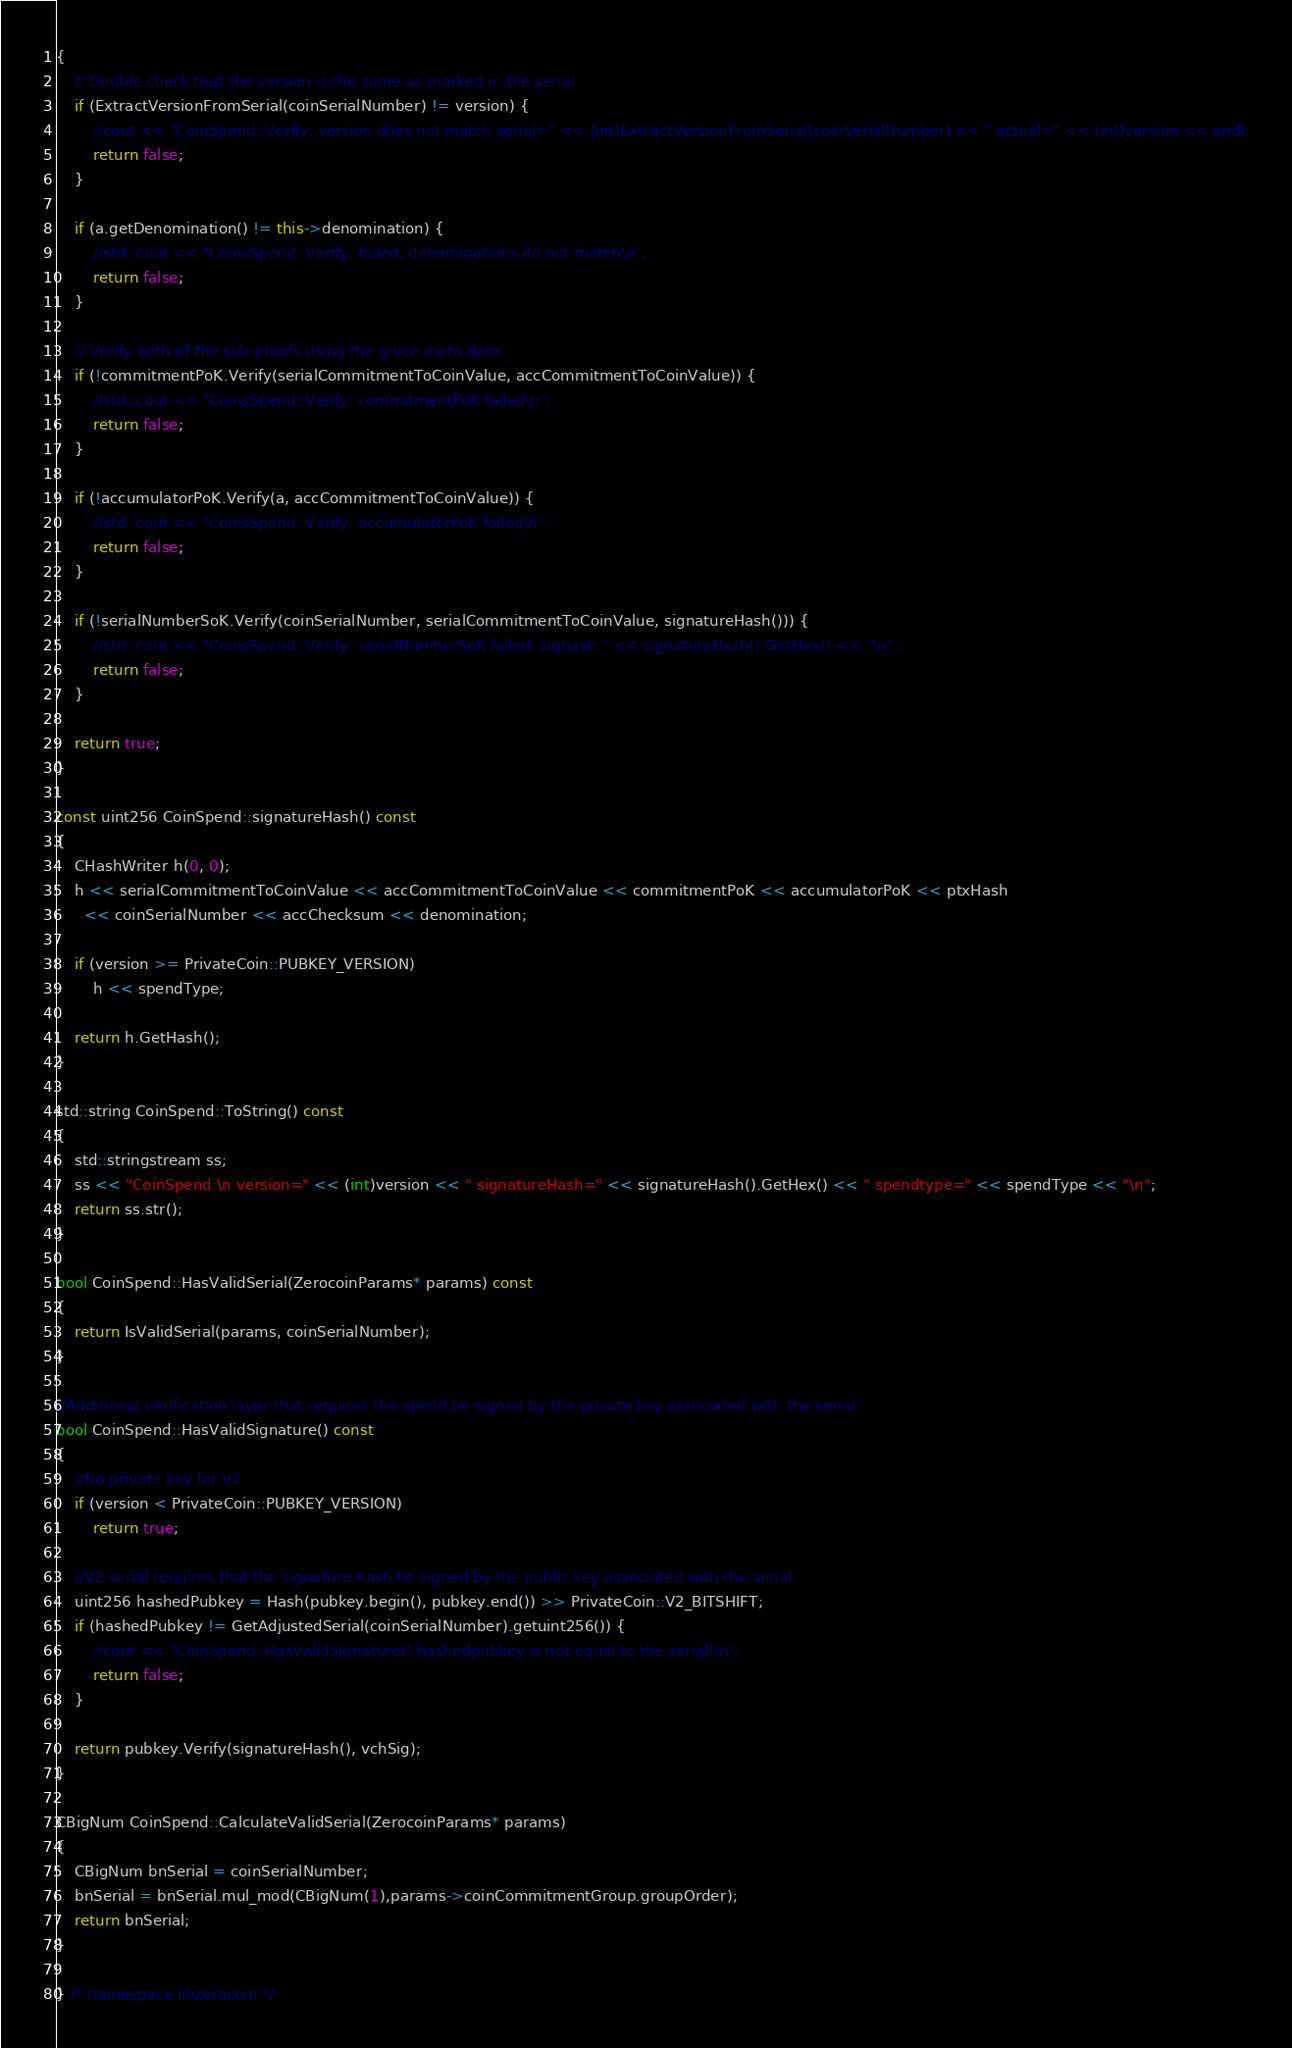Convert code to text. <code><loc_0><loc_0><loc_500><loc_500><_C++_>{
    // Double check that the version is the same as marked in the serial
    if (ExtractVersionFromSerial(coinSerialNumber) != version) {
        //cout << "CoinSpend::Verify: version does not match serial=" << (int)ExtractVersionFromSerial(coinSerialNumber) << " actual=" << (int)version << endl;
        return false;
    }

    if (a.getDenomination() != this->denomination) {
        //std::cout << "CoinsSpend::Verify: failed, denominations do not match\n";
        return false;
    }

    // Verify both of the sub-proofs using the given meta-data
    if (!commitmentPoK.Verify(serialCommitmentToCoinValue, accCommitmentToCoinValue)) {
        //std::cout << "CoinsSpend::Verify: commitmentPoK failed\n";
        return false;
    }

    if (!accumulatorPoK.Verify(a, accCommitmentToCoinValue)) {
        //std::cout << "CoinsSpend::Verify: accumulatorPoK failed\n";
        return false;
    }

    if (!serialNumberSoK.Verify(coinSerialNumber, serialCommitmentToCoinValue, signatureHash())) {
        //std::cout << "CoinsSpend::Verify: serialNumberSoK failed. sighash:" << signatureHash().GetHex() << "\n";
        return false;
    }

    return true;
}

const uint256 CoinSpend::signatureHash() const
{
    CHashWriter h(0, 0);
    h << serialCommitmentToCoinValue << accCommitmentToCoinValue << commitmentPoK << accumulatorPoK << ptxHash
      << coinSerialNumber << accChecksum << denomination;

    if (version >= PrivateCoin::PUBKEY_VERSION)
        h << spendType;

    return h.GetHash();
}

std::string CoinSpend::ToString() const
{
    std::stringstream ss;
    ss << "CoinSpend:\n version=" << (int)version << " signatureHash=" << signatureHash().GetHex() << " spendtype=" << spendType << "\n";
    return ss.str();
}

bool CoinSpend::HasValidSerial(ZerocoinParams* params) const
{
    return IsValidSerial(params, coinSerialNumber);
}

//Additional verification layer that requires the spend be signed by the private key associated with the serial
bool CoinSpend::HasValidSignature() const
{
    //No private key for V1
    if (version < PrivateCoin::PUBKEY_VERSION)
        return true;

    //V2 serial requires that the signature hash be signed by the public key associated with the serial
    uint256 hashedPubkey = Hash(pubkey.begin(), pubkey.end()) >> PrivateCoin::V2_BITSHIFT;
    if (hashedPubkey != GetAdjustedSerial(coinSerialNumber).getuint256()) {
        //cout << "CoinSpend::HasValidSignature() hashedpubkey is not equal to the serial!\n";
        return false;
    }

    return pubkey.Verify(signatureHash(), vchSig);
}

CBigNum CoinSpend::CalculateValidSerial(ZerocoinParams* params)
{
    CBigNum bnSerial = coinSerialNumber;
    bnSerial = bnSerial.mul_mod(CBigNum(1),params->coinCommitmentGroup.groupOrder);
    return bnSerial;
}

} /* namespace libzerocoin */
</code> 